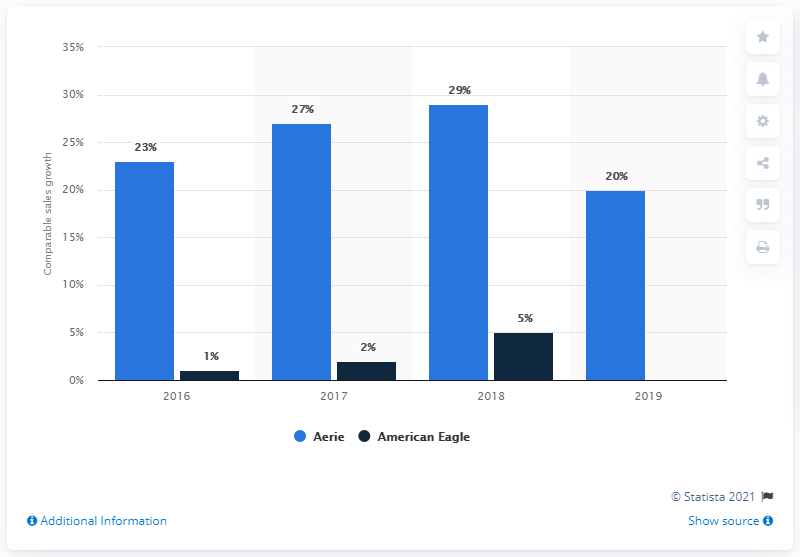Can you analyze the trend for American Eagle's growth shown here? Certainly. American Eagle's comparative sales growth depicts a decreasing trend from 2016 to 2019, with a notable dip in 2018 where the growth fell to just 5%, before recovering slightly to 20% in 2019. 